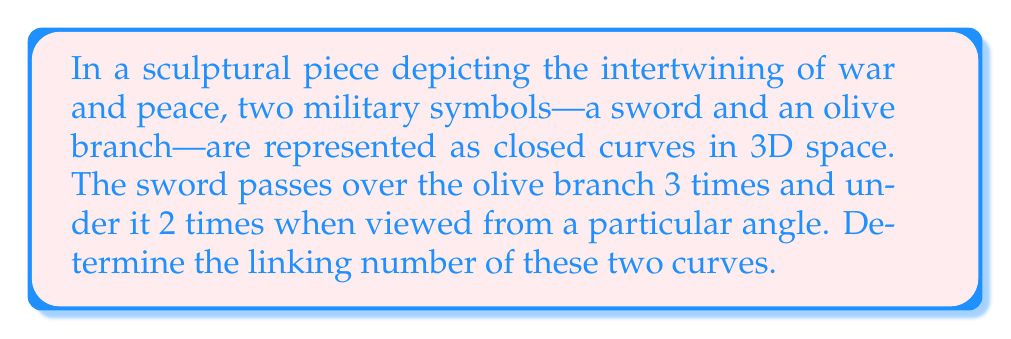Teach me how to tackle this problem. To determine the linking number, we follow these steps:

1) The linking number is defined as half the sum of the signed crossings when projecting the link onto a plane.

2) In this case, we are given a specific projection where:
   - The sword passes over the olive branch 3 times
   - The sword passes under the olive branch 2 times

3) We assign:
   - +1 to each instance where the sword passes over the olive branch
   - -1 to each instance where the sword passes under the olive branch

4) Calculate the sum of signed crossings:
   $$(3 \times (+1)) + (2 \times (-1)) = 3 - 2 = 1$$

5) The linking number is half of this sum:
   $$\text{Linking Number} = \frac{1}{2} \times 1 = \frac{1}{2}$$

6) The linking number is always an integer or half-integer, so $\frac{1}{2}$ is a valid result.

This non-zero linking number indicates that the sword and olive branch are indeed linked and cannot be separated without cutting one of the curves, symbolizing the intricate relationship between war and peace in the artist's installation.
Answer: $\frac{1}{2}$ 